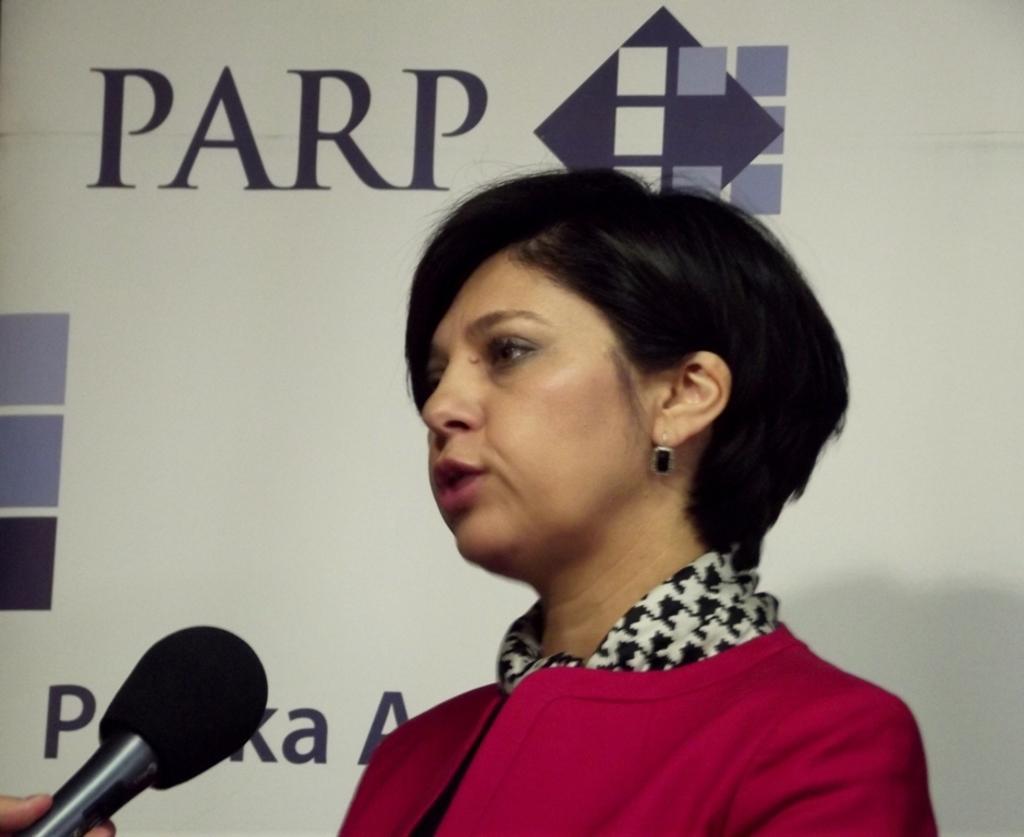Please provide a concise description of this image. In the center of the image, we can see a lady and there is a person's hand holding a mic. In the background, there is a board and we can see some text and logos. 